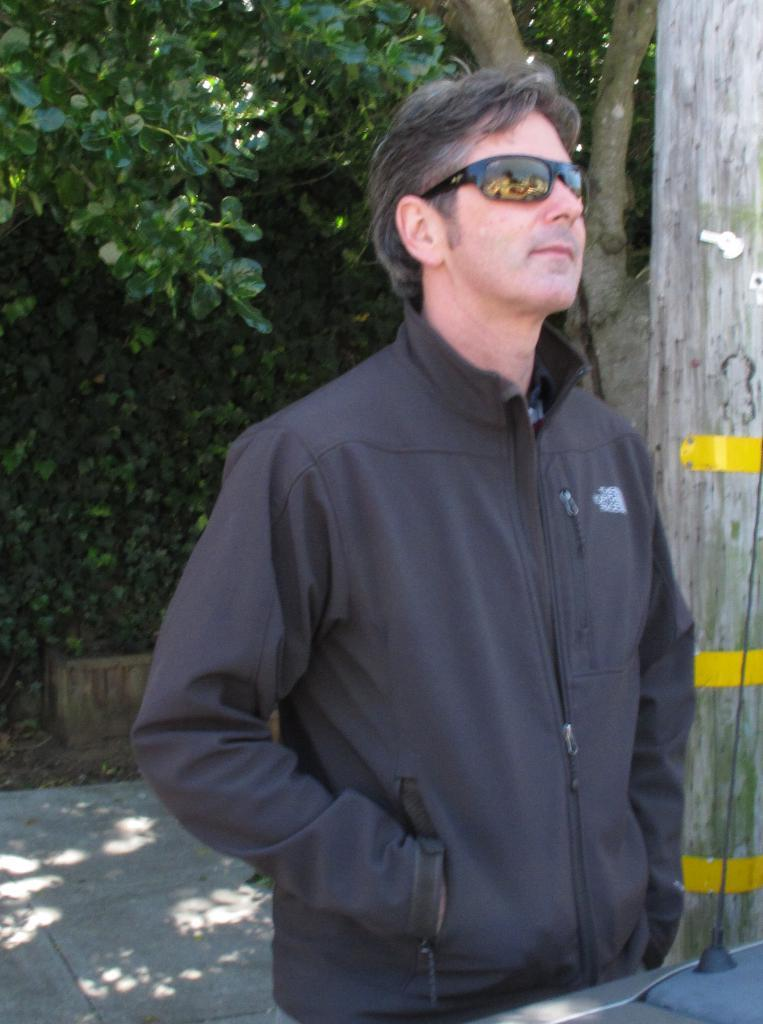What is the setting of the image? The image has an outside view. Can you describe the person in the image? There is a person standing in the foreground, and they are wearing sunglasses. What can be seen in the background of the image? There is a tree in the background. Reasoning: Let' Let's think step by step in order to produce the conversation. We start by identifying the setting of the image, which is outdoors. Then, we describe the person in the foreground, noting their sunglasses. Finally, we mention the tree in the background as a key feature of the image. Each question is designed to elicit a specific detail about the image that is known from the provided facts. Absurd Question/Answer: What type of payment is being made by the person in the image? There is no indication of any payment being made in the image; the person is simply standing and wearing sunglasses. What kind of ship can be seen sailing in the background of the image? There is no ship present in the image; it features an outdoor scene with a person and a tree in the background. What type of land is visible in the image? There is no specific type of land mentioned or visible in the image; it features an outdoor scene with a person and a tree in the background. 